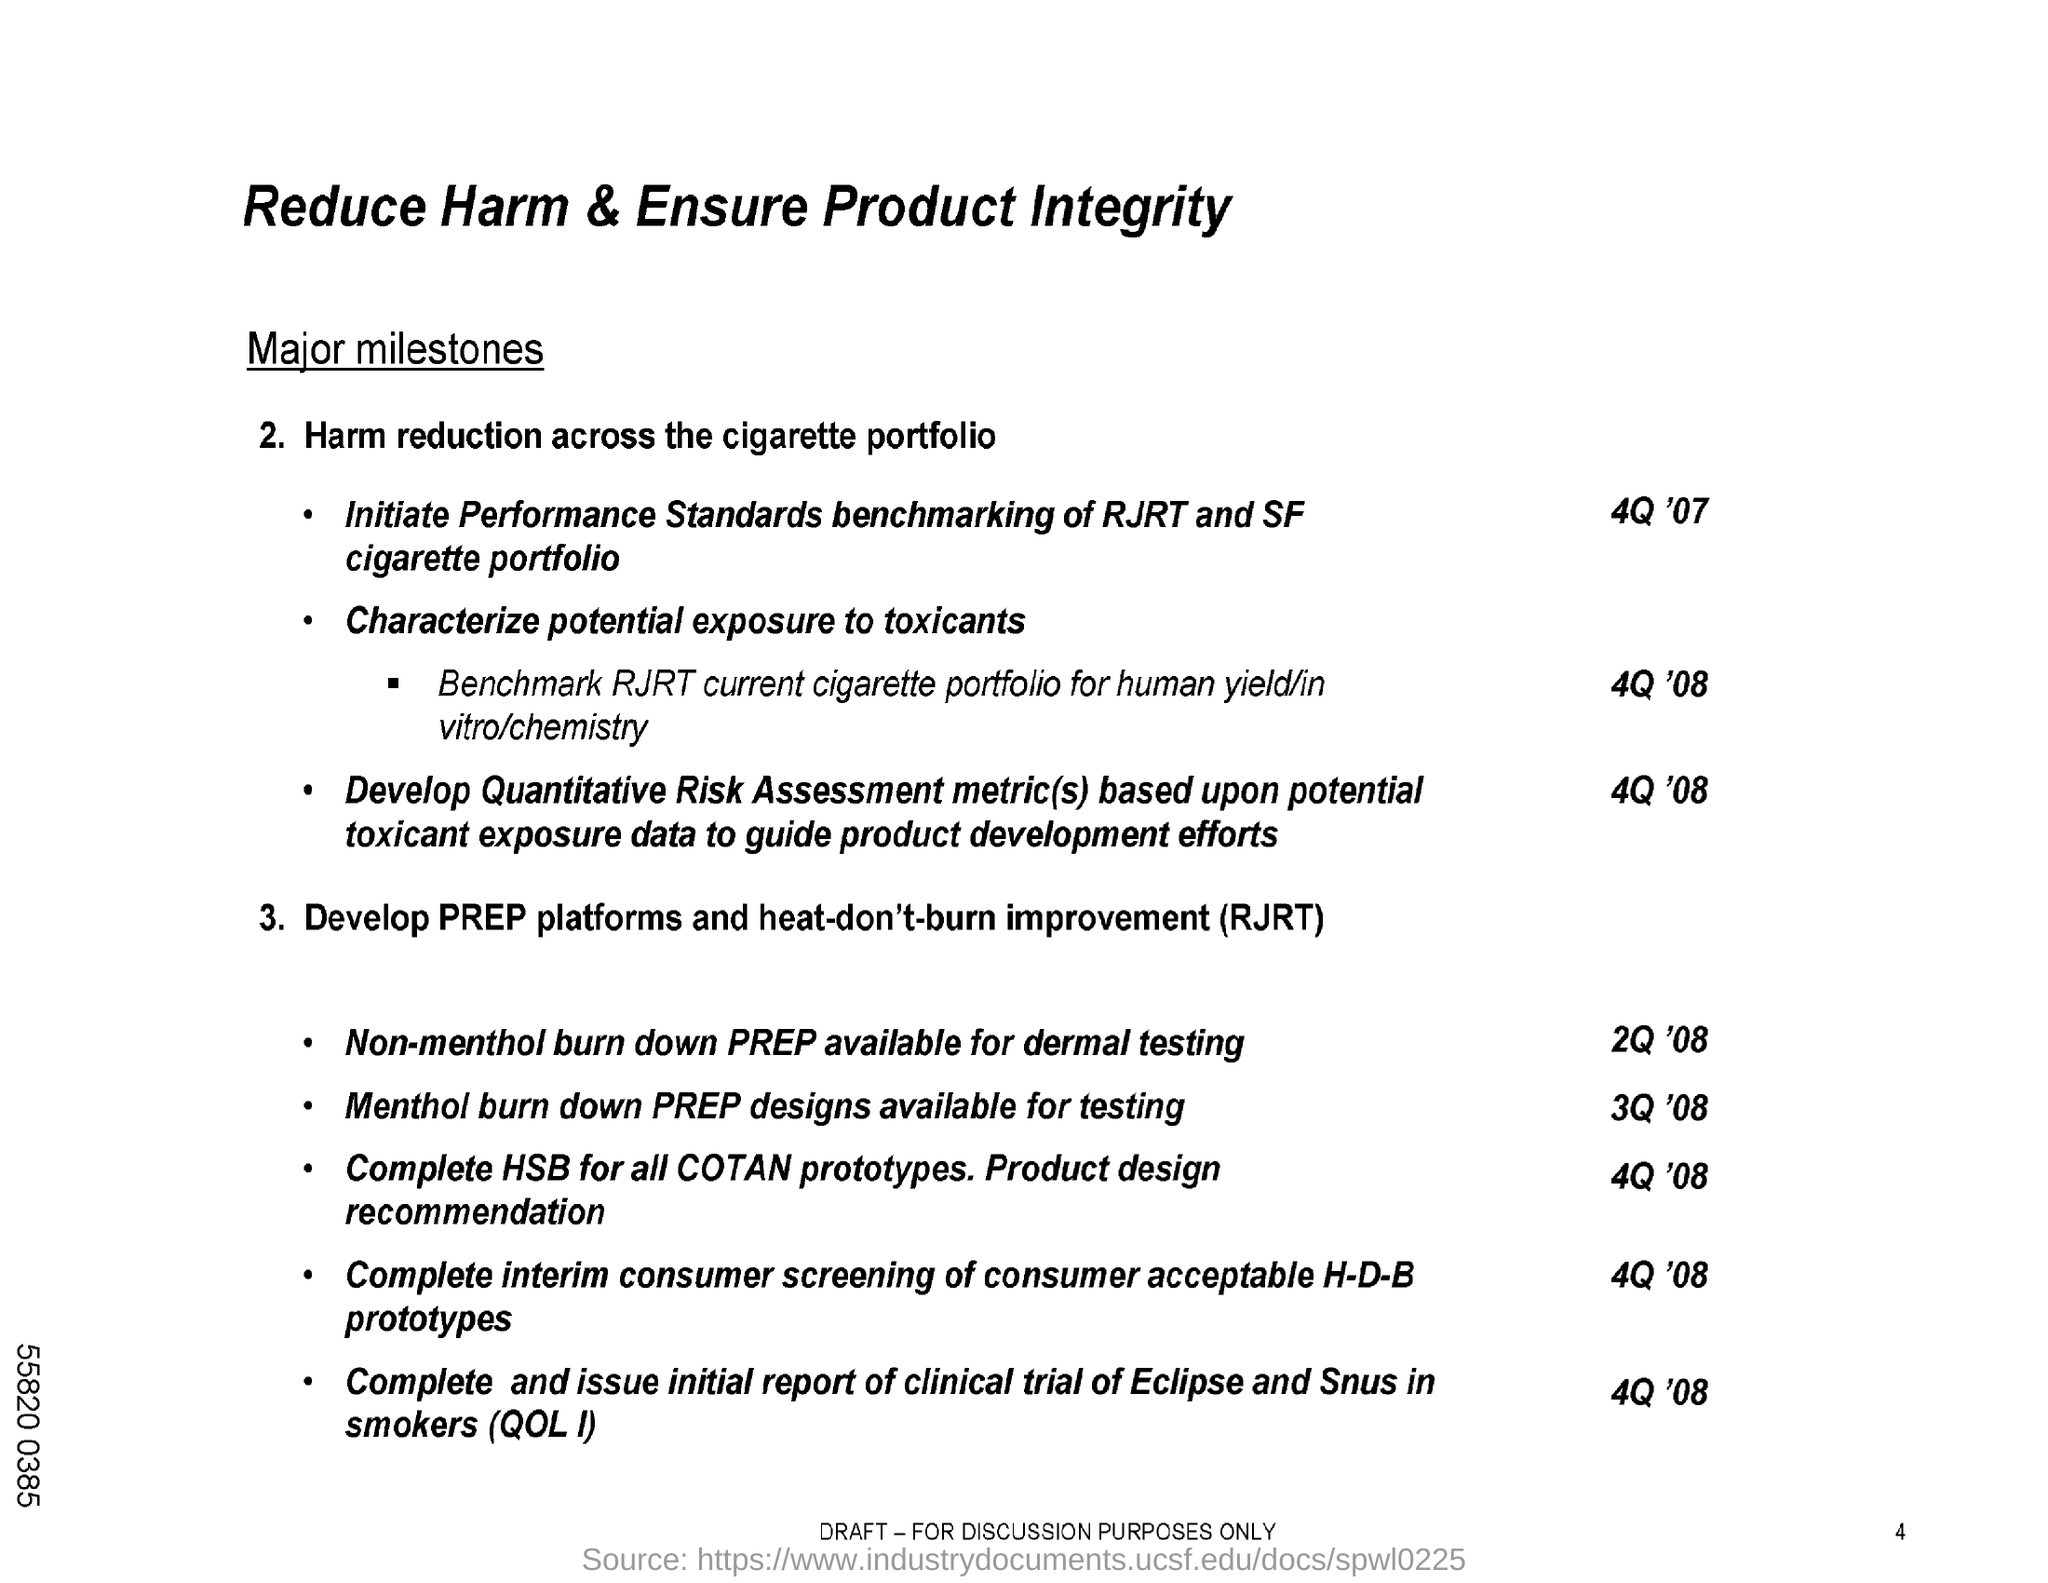Mention a couple of crucial points in this snapshot. The second title in this document is 'Major Milestones.' The document's title is 'Reduce Harm & Ensure Product Integrity'. 